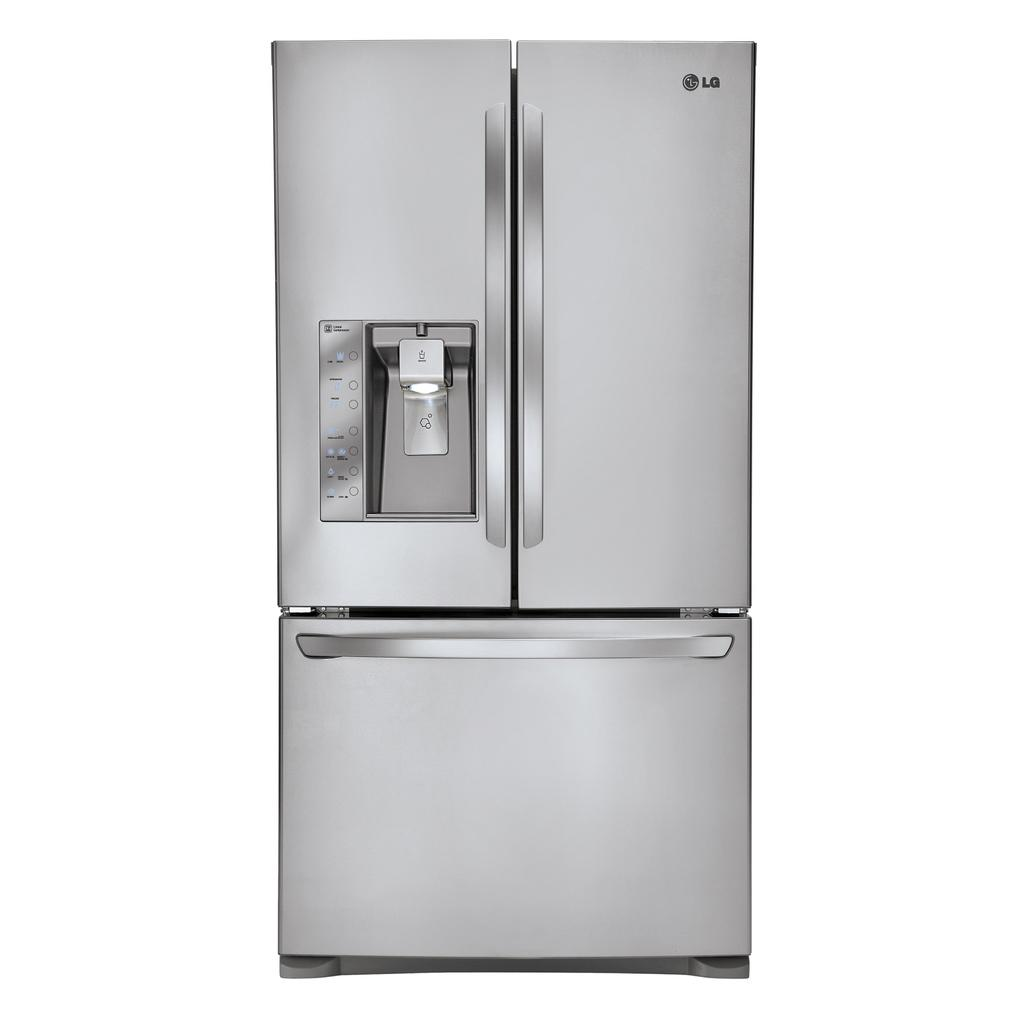<image>
Summarize the visual content of the image. A stainless steel refrigerator of the LG brand with a drawer freezer 